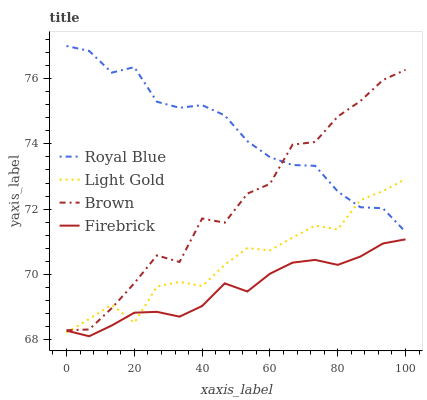Does Light Gold have the minimum area under the curve?
Answer yes or no. No. Does Light Gold have the maximum area under the curve?
Answer yes or no. No. Is Light Gold the smoothest?
Answer yes or no. No. Is Light Gold the roughest?
Answer yes or no. No. Does Light Gold have the lowest value?
Answer yes or no. No. Does Light Gold have the highest value?
Answer yes or no. No. Is Firebrick less than Royal Blue?
Answer yes or no. Yes. Is Royal Blue greater than Firebrick?
Answer yes or no. Yes. Does Firebrick intersect Royal Blue?
Answer yes or no. No. 